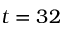Convert formula to latex. <formula><loc_0><loc_0><loc_500><loc_500>t = 3 2</formula> 